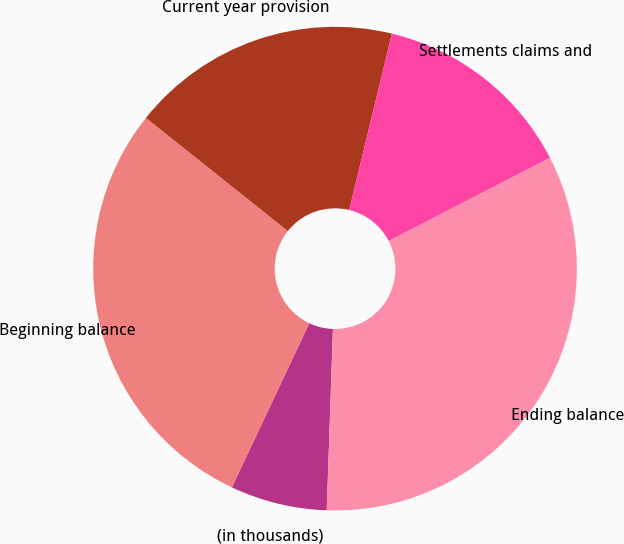<chart> <loc_0><loc_0><loc_500><loc_500><pie_chart><fcel>(in thousands)<fcel>Beginning balance<fcel>Current year provision<fcel>Settlements claims and<fcel>Ending balance<nl><fcel>6.47%<fcel>28.7%<fcel>18.07%<fcel>13.65%<fcel>33.12%<nl></chart> 